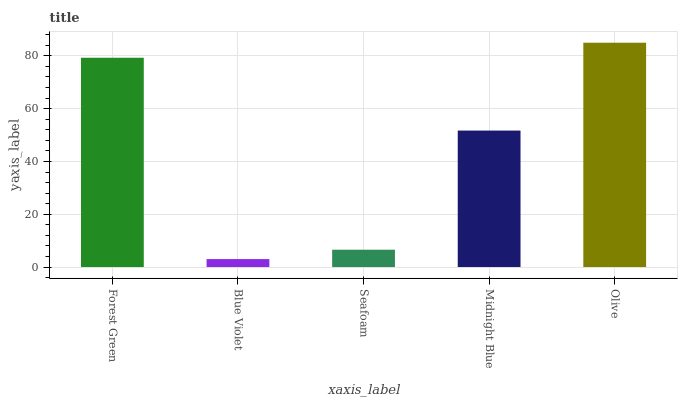Is Seafoam the minimum?
Answer yes or no. No. Is Seafoam the maximum?
Answer yes or no. No. Is Seafoam greater than Blue Violet?
Answer yes or no. Yes. Is Blue Violet less than Seafoam?
Answer yes or no. Yes. Is Blue Violet greater than Seafoam?
Answer yes or no. No. Is Seafoam less than Blue Violet?
Answer yes or no. No. Is Midnight Blue the high median?
Answer yes or no. Yes. Is Midnight Blue the low median?
Answer yes or no. Yes. Is Seafoam the high median?
Answer yes or no. No. Is Olive the low median?
Answer yes or no. No. 